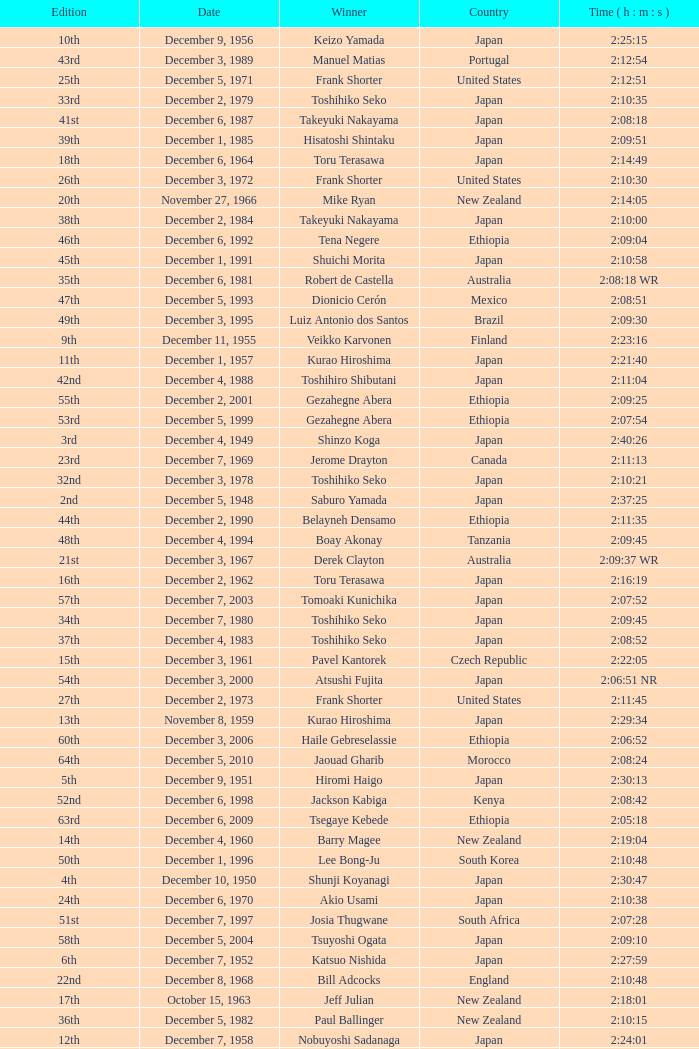On what date was the 48th Edition raced? December 4, 1994. 